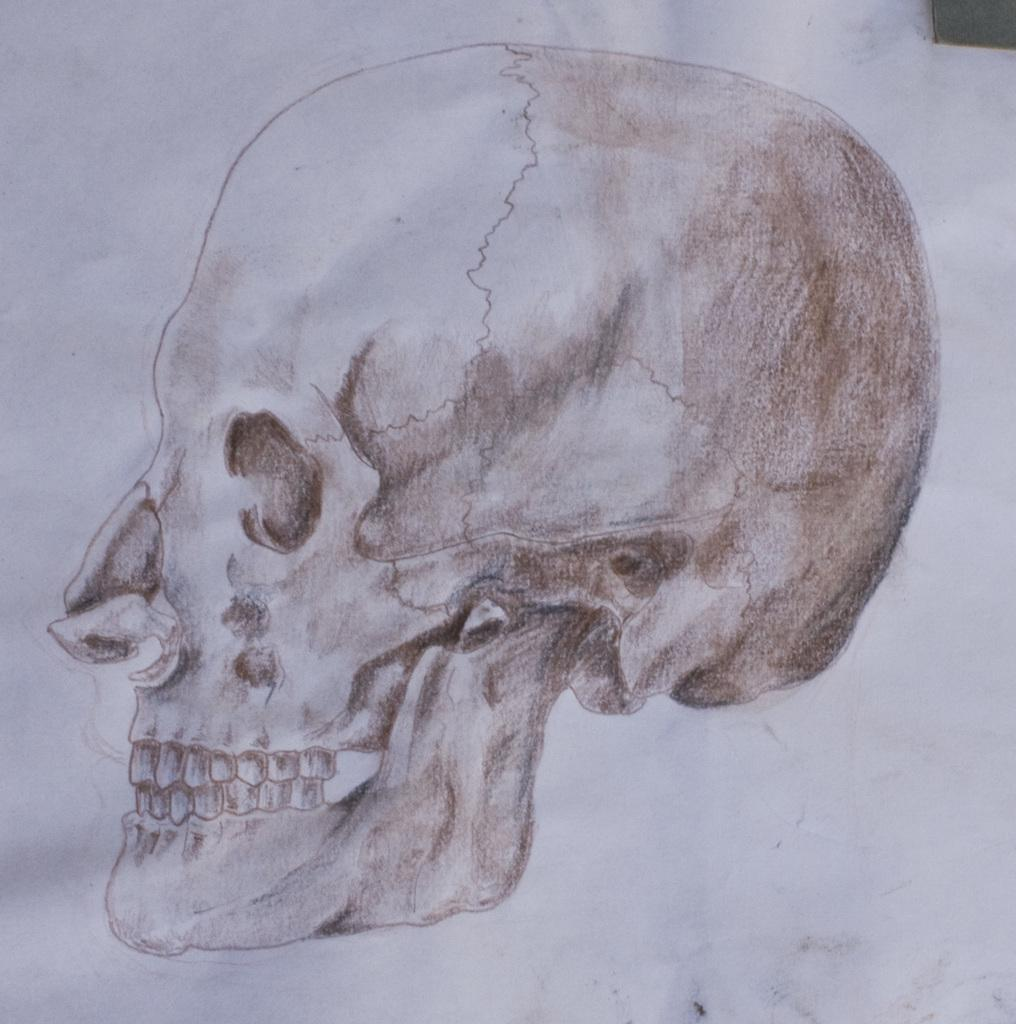What is depicted in the drawing in the image? There is a drawing of a skull in the image. Where is the drawing located? The drawing is on a wall. What type of beast is shown next to the skull in the image? There is no beast present in the image; it only features a drawing of a skull on a wall. 